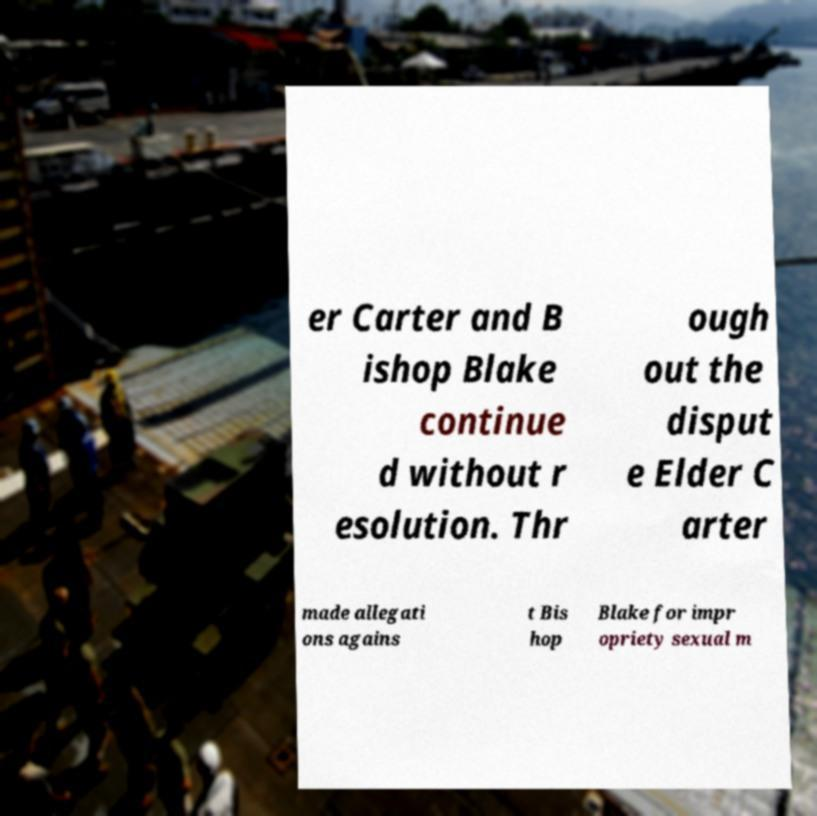Could you assist in decoding the text presented in this image and type it out clearly? er Carter and B ishop Blake continue d without r esolution. Thr ough out the disput e Elder C arter made allegati ons agains t Bis hop Blake for impr opriety sexual m 